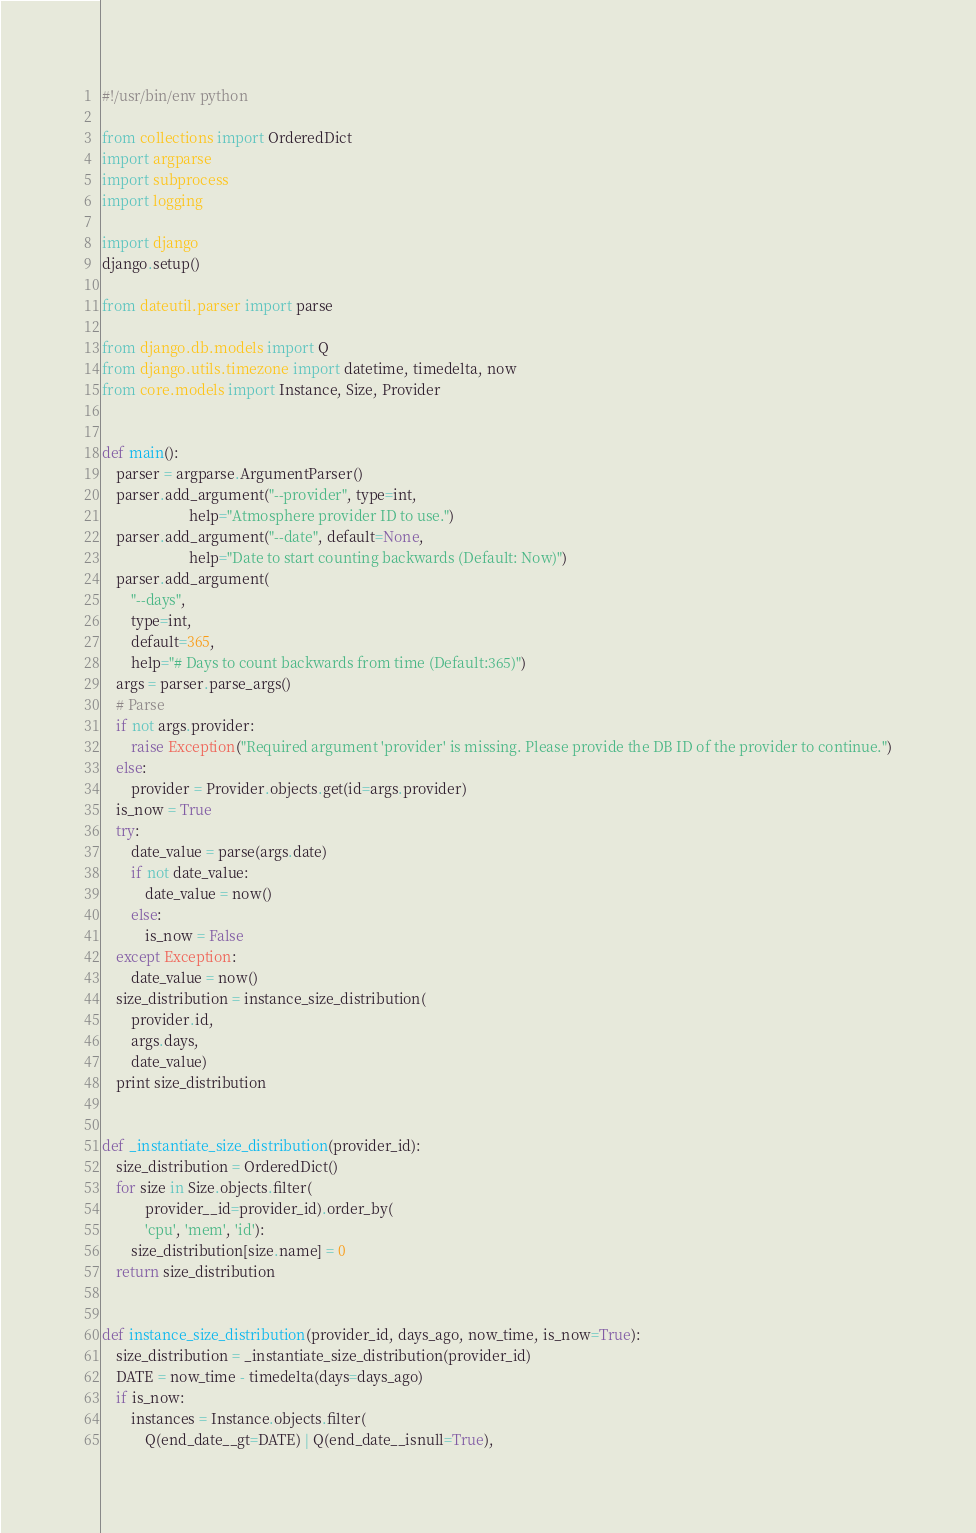<code> <loc_0><loc_0><loc_500><loc_500><_Python_>#!/usr/bin/env python

from collections import OrderedDict
import argparse
import subprocess
import logging

import django
django.setup()

from dateutil.parser import parse

from django.db.models import Q
from django.utils.timezone import datetime, timedelta, now
from core.models import Instance, Size, Provider


def main():
    parser = argparse.ArgumentParser()
    parser.add_argument("--provider", type=int,
                        help="Atmosphere provider ID to use.")
    parser.add_argument("--date", default=None,
                        help="Date to start counting backwards (Default: Now)")
    parser.add_argument(
        "--days",
        type=int,
        default=365,
        help="# Days to count backwards from time (Default:365)")
    args = parser.parse_args()
    # Parse
    if not args.provider:
        raise Exception("Required argument 'provider' is missing. Please provide the DB ID of the provider to continue.")
    else:
        provider = Provider.objects.get(id=args.provider)
    is_now = True
    try:
        date_value = parse(args.date)
        if not date_value:
            date_value = now()
        else:
            is_now = False
    except Exception:
        date_value = now()
    size_distribution = instance_size_distribution(
        provider.id,
        args.days,
        date_value)
    print size_distribution


def _instantiate_size_distribution(provider_id):
    size_distribution = OrderedDict()
    for size in Size.objects.filter(
            provider__id=provider_id).order_by(
            'cpu', 'mem', 'id'):
        size_distribution[size.name] = 0
    return size_distribution


def instance_size_distribution(provider_id, days_ago, now_time, is_now=True):
    size_distribution = _instantiate_size_distribution(provider_id)
    DATE = now_time - timedelta(days=days_ago)
    if is_now:
        instances = Instance.objects.filter(
            Q(end_date__gt=DATE) | Q(end_date__isnull=True),</code> 